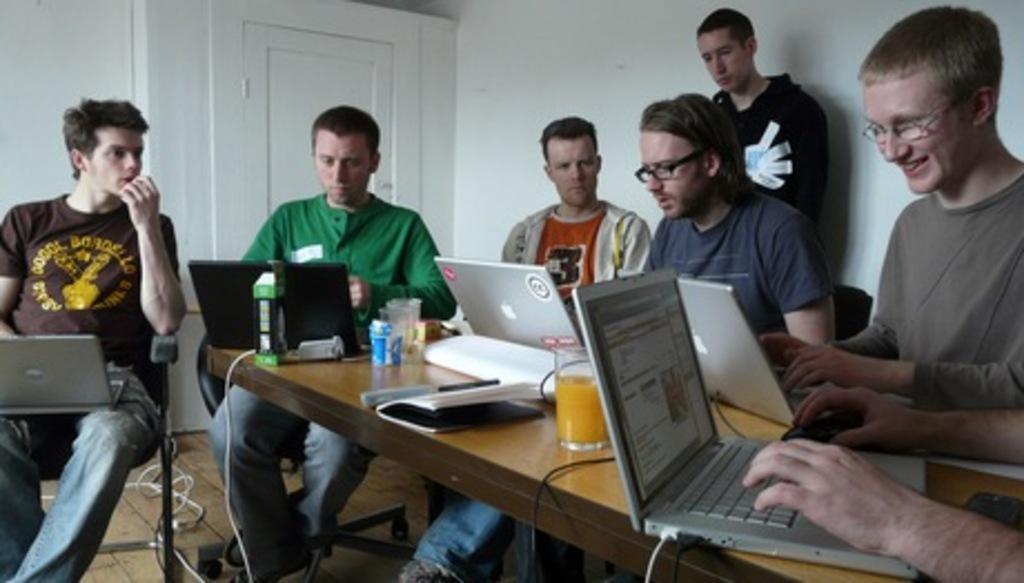Describe this image in one or two sentences. In the image we can see there are people who are sitting on chair and in front of them there are laptops on the table and juice glass. 